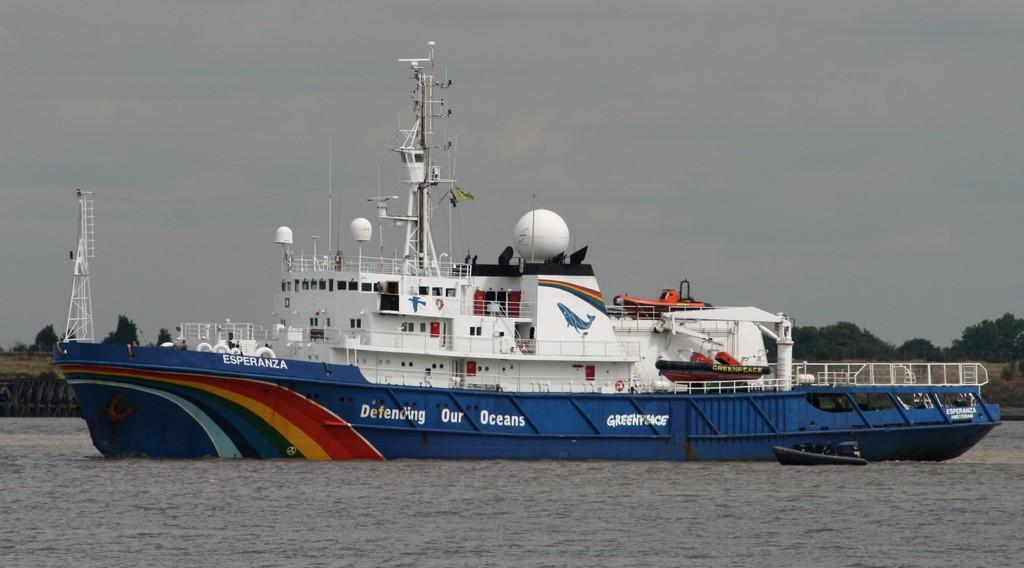<image>
Create a compact narrative representing the image presented. a boat that has the word defending on it 